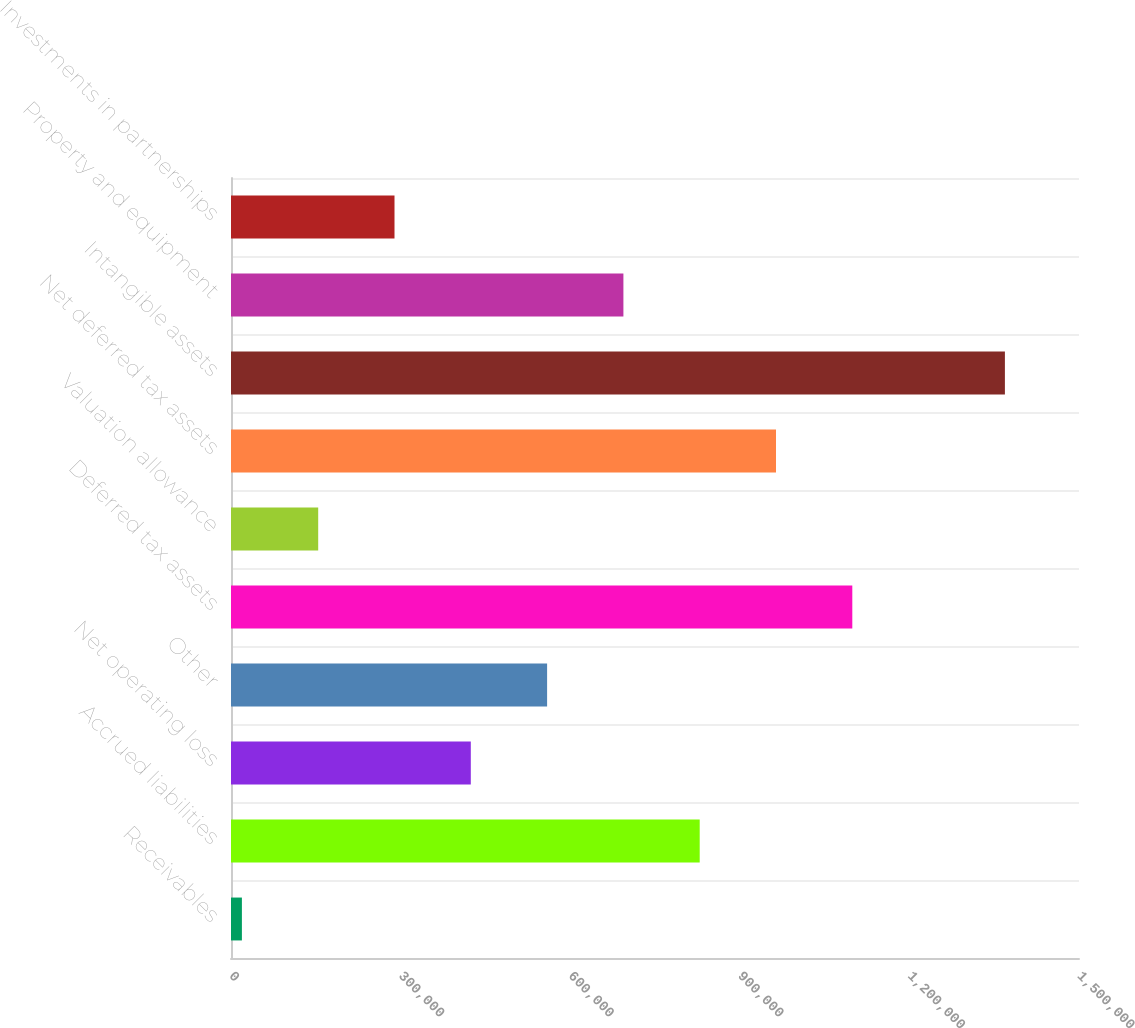Convert chart. <chart><loc_0><loc_0><loc_500><loc_500><bar_chart><fcel>Receivables<fcel>Accrued liabilities<fcel>Net operating loss<fcel>Other<fcel>Deferred tax assets<fcel>Valuation allowance<fcel>Net deferred tax assets<fcel>Intangible assets<fcel>Property and equipment<fcel>Investments in partnerships<nl><fcel>19283<fcel>829074<fcel>424178<fcel>559143<fcel>1.099e+06<fcel>154248<fcel>964039<fcel>1.36893e+06<fcel>694108<fcel>289213<nl></chart> 